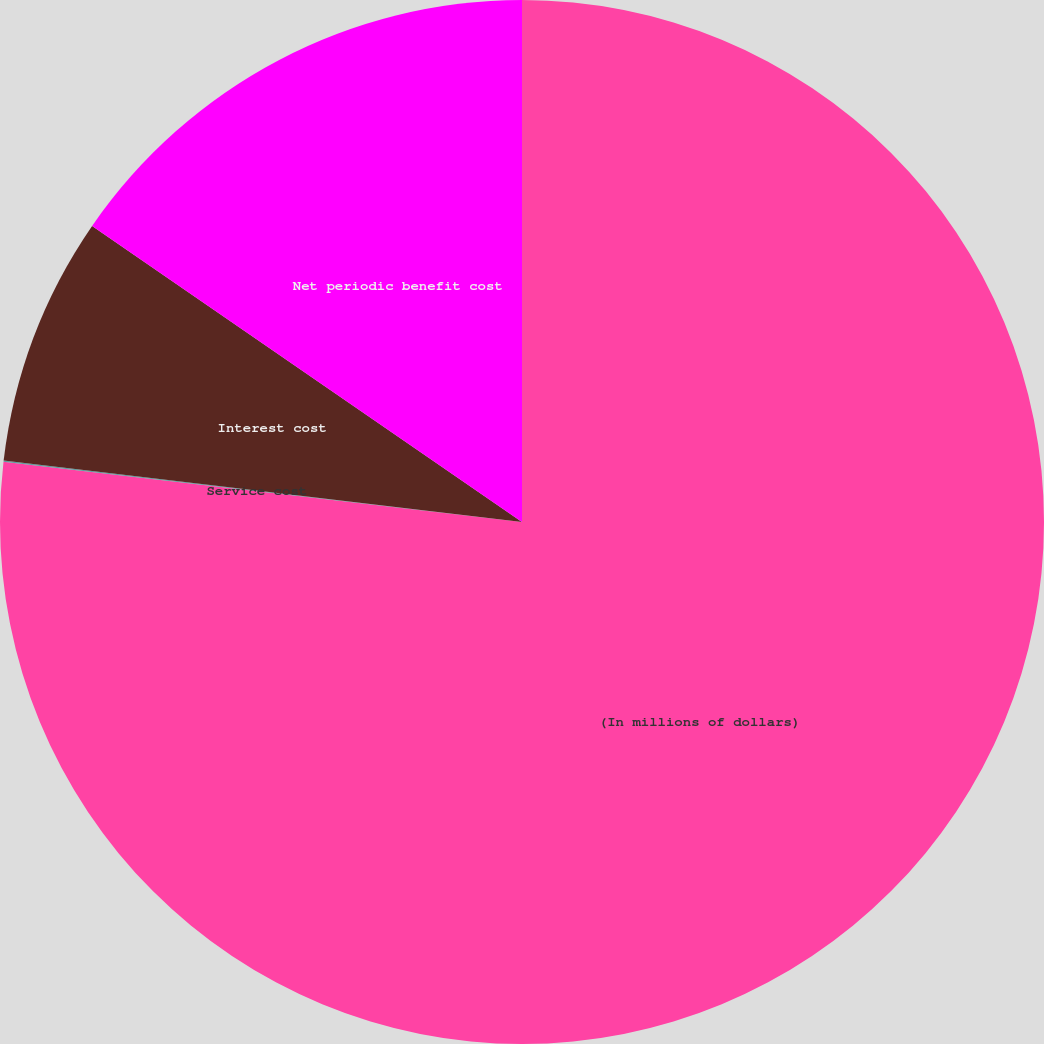Convert chart to OTSL. <chart><loc_0><loc_0><loc_500><loc_500><pie_chart><fcel>(In millions of dollars)<fcel>Service cost<fcel>Interest cost<fcel>Net periodic benefit cost<nl><fcel>76.84%<fcel>0.04%<fcel>7.72%<fcel>15.4%<nl></chart> 